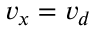Convert formula to latex. <formula><loc_0><loc_0><loc_500><loc_500>v _ { x } = v _ { d }</formula> 